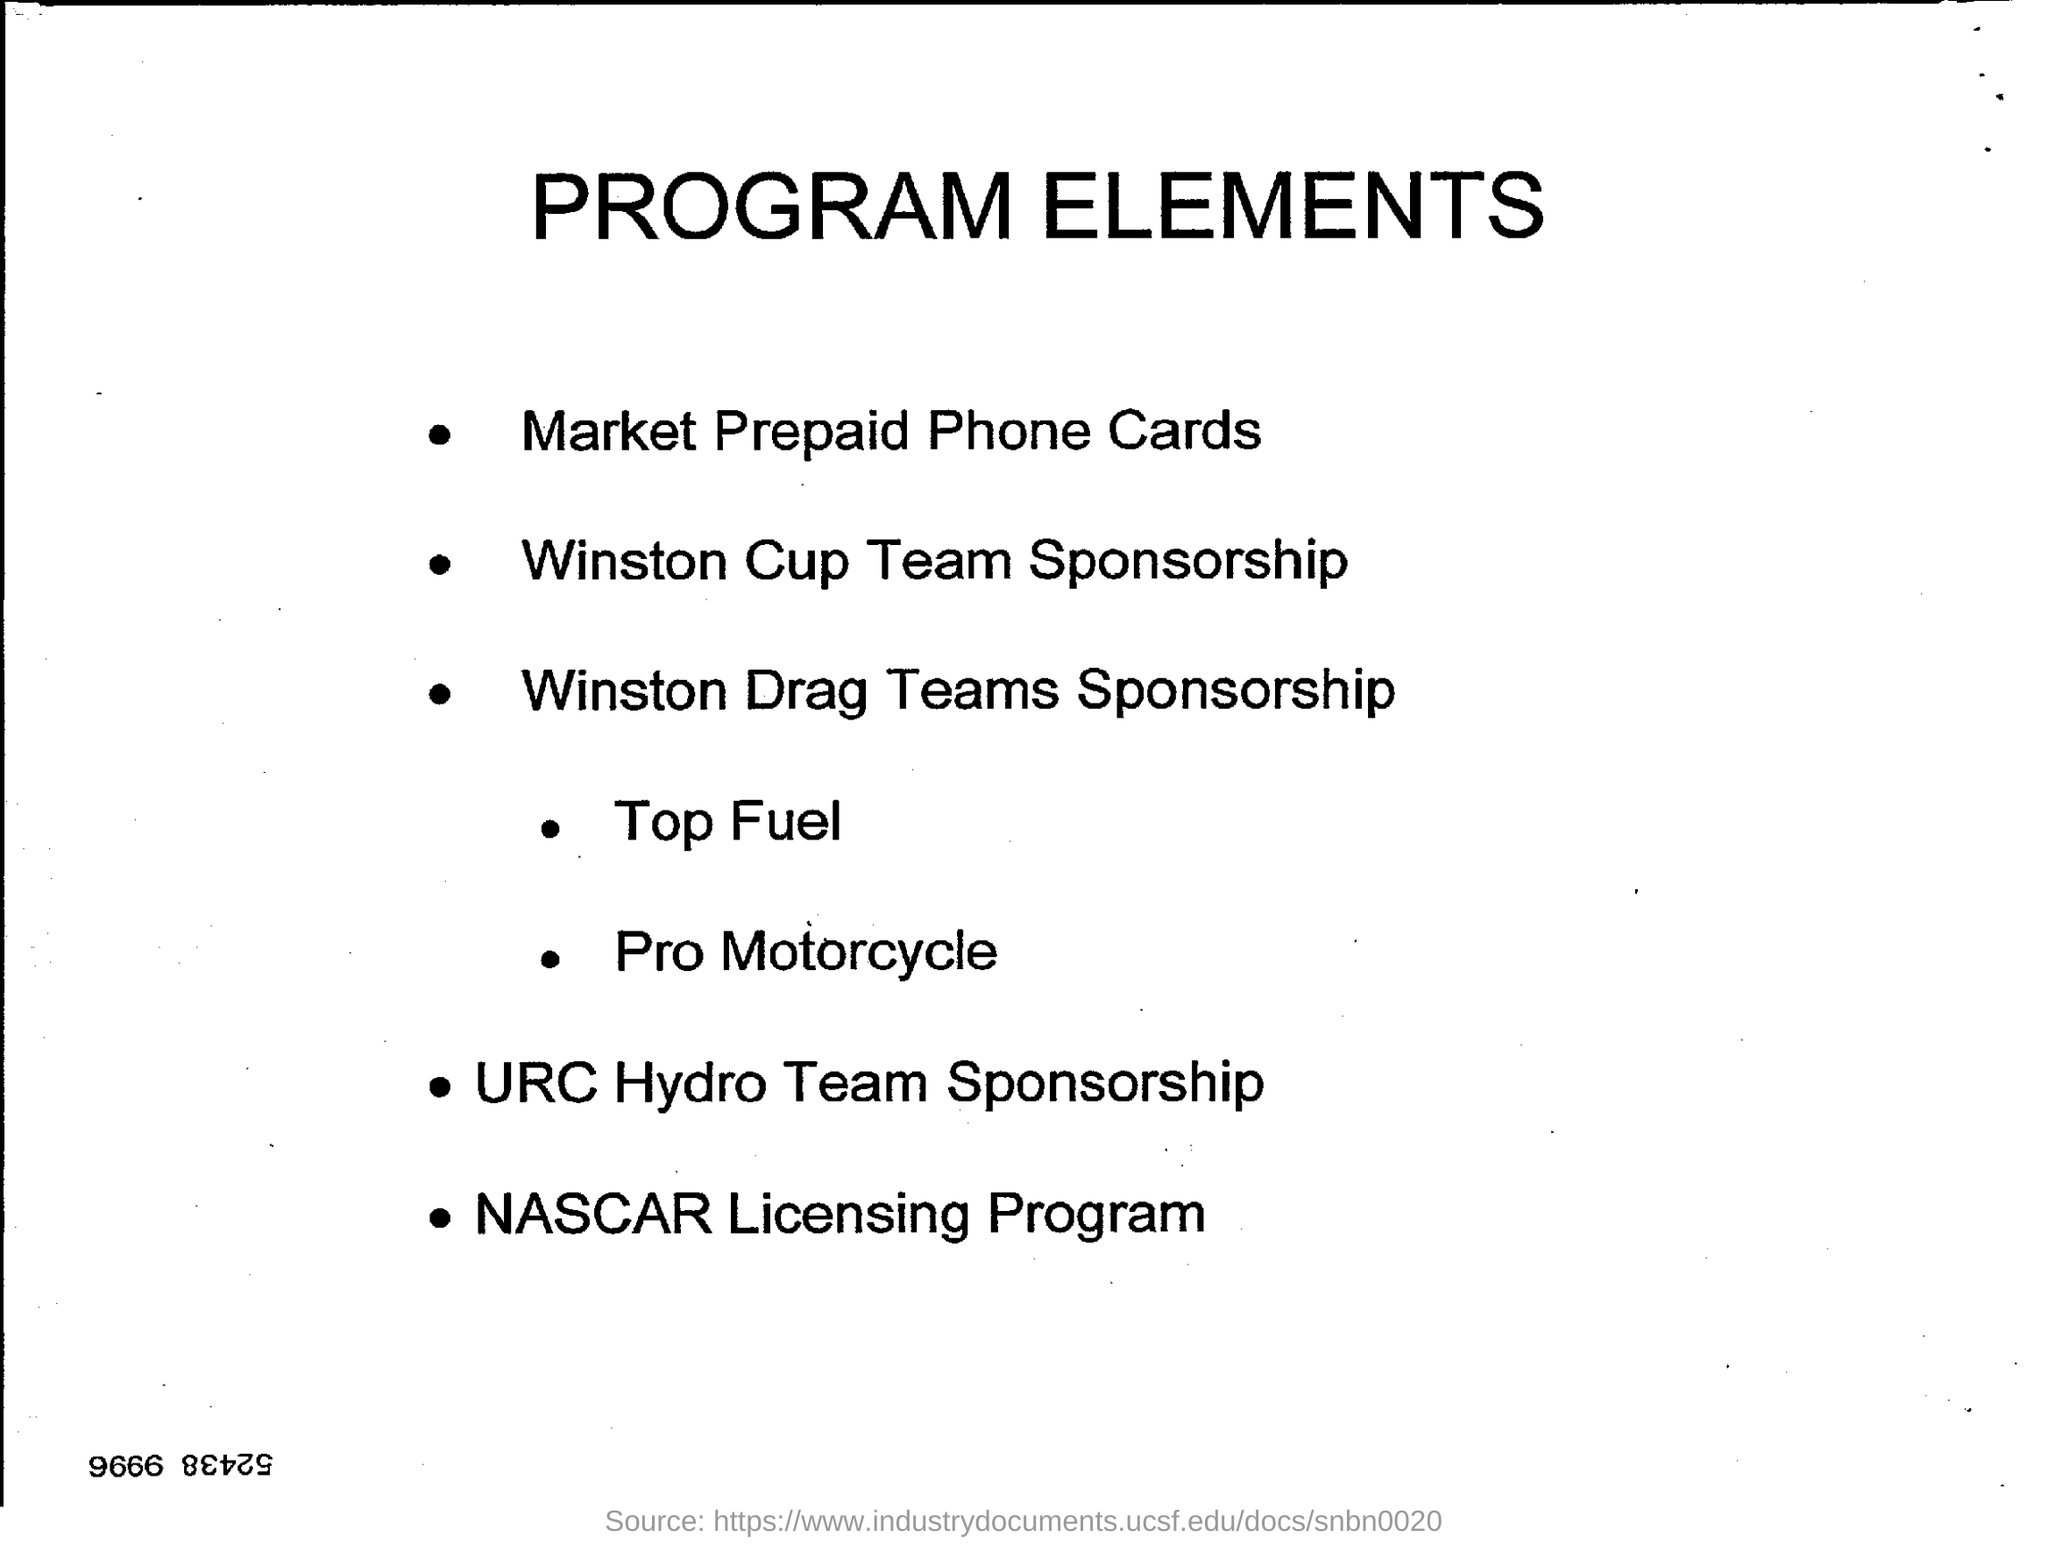What does the heading of the document say?
Give a very brief answer. PROGRAM ELEMENTS. What is the first point?
Your answer should be compact. Market Prepaid Phone Cards. What is the name of the Licensing Program?
Make the answer very short. NASCAR. What kind of sponsorship is URC?
Offer a terse response. URC Hydro Team Sponsorship. 